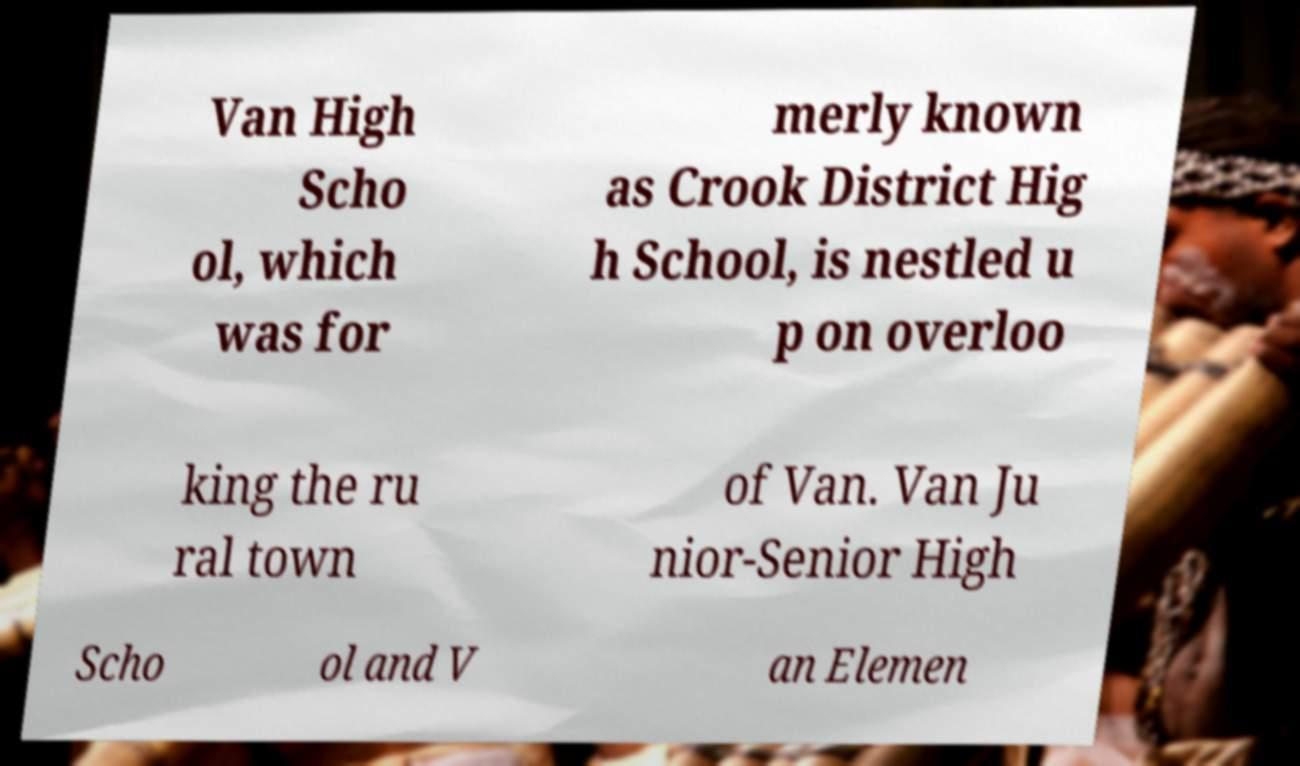Can you accurately transcribe the text from the provided image for me? Van High Scho ol, which was for merly known as Crook District Hig h School, is nestled u p on overloo king the ru ral town of Van. Van Ju nior-Senior High Scho ol and V an Elemen 